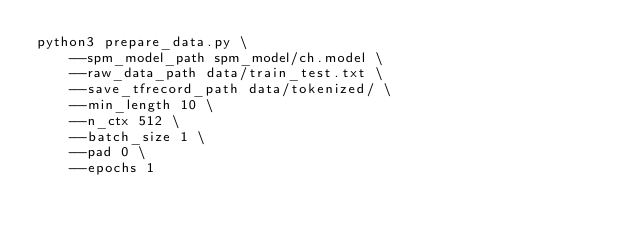<code> <loc_0><loc_0><loc_500><loc_500><_Bash_>python3 prepare_data.py \
    --spm_model_path spm_model/ch.model \
    --raw_data_path data/train_test.txt \
    --save_tfrecord_path data/tokenized/ \
    --min_length 10 \
    --n_ctx 512 \
    --batch_size 1 \
    --pad 0 \
    --epochs 1</code> 